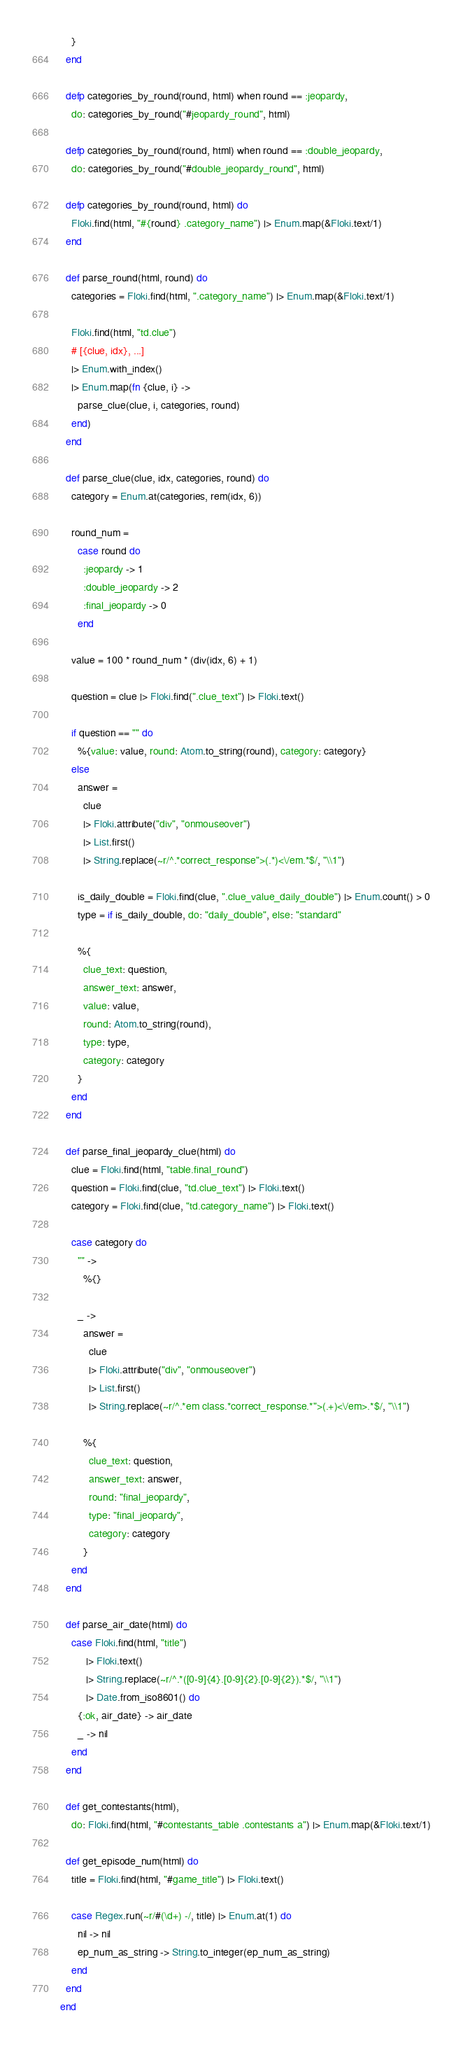Convert code to text. <code><loc_0><loc_0><loc_500><loc_500><_Elixir_>    }
  end

  defp categories_by_round(round, html) when round == :jeopardy,
    do: categories_by_round("#jeopardy_round", html)

  defp categories_by_round(round, html) when round == :double_jeopardy,
    do: categories_by_round("#double_jeopardy_round", html)

  defp categories_by_round(round, html) do
    Floki.find(html, "#{round} .category_name") |> Enum.map(&Floki.text/1)
  end

  def parse_round(html, round) do
    categories = Floki.find(html, ".category_name") |> Enum.map(&Floki.text/1)

    Floki.find(html, "td.clue")
    # [{clue, idx}, ...]
    |> Enum.with_index()
    |> Enum.map(fn {clue, i} ->
      parse_clue(clue, i, categories, round)
    end)
  end

  def parse_clue(clue, idx, categories, round) do
    category = Enum.at(categories, rem(idx, 6))

    round_num =
      case round do
        :jeopardy -> 1
        :double_jeopardy -> 2
        :final_jeopardy -> 0
      end

    value = 100 * round_num * (div(idx, 6) + 1)

    question = clue |> Floki.find(".clue_text") |> Floki.text()

    if question == "" do
      %{value: value, round: Atom.to_string(round), category: category}
    else
      answer =
        clue
        |> Floki.attribute("div", "onmouseover")
        |> List.first()
        |> String.replace(~r/^.*correct_response">(.*)<\/em.*$/, "\\1")

      is_daily_double = Floki.find(clue, ".clue_value_daily_double") |> Enum.count() > 0
      type = if is_daily_double, do: "daily_double", else: "standard"

      %{
        clue_text: question,
        answer_text: answer,
        value: value,
        round: Atom.to_string(round),
        type: type,
        category: category
      }
    end
  end

  def parse_final_jeopardy_clue(html) do
    clue = Floki.find(html, "table.final_round")
    question = Floki.find(clue, "td.clue_text") |> Floki.text()
    category = Floki.find(clue, "td.category_name") |> Floki.text()

    case category do
      "" ->
        %{}

      _ ->
        answer =
          clue
          |> Floki.attribute("div", "onmouseover")
          |> List.first()
          |> String.replace(~r/^.*em class.*correct_response.*">(.+)<\/em>.*$/, "\\1")

        %{
          clue_text: question,
          answer_text: answer,
          round: "final_jeopardy",
          type: "final_jeopardy",
          category: category
        }
    end
  end

  def parse_air_date(html) do
    case Floki.find(html, "title")
         |> Floki.text()
         |> String.replace(~r/^.*([0-9]{4}.[0-9]{2}.[0-9]{2}).*$/, "\\1")
         |> Date.from_iso8601() do
      {:ok, air_date} -> air_date
      _ -> nil
    end
  end

  def get_contestants(html),
    do: Floki.find(html, "#contestants_table .contestants a") |> Enum.map(&Floki.text/1)

  def get_episode_num(html) do
    title = Floki.find(html, "#game_title") |> Floki.text()

    case Regex.run(~r/#(\d+) -/, title) |> Enum.at(1) do
      nil -> nil
      ep_num_as_string -> String.to_integer(ep_num_as_string)
    end
  end
end
</code> 